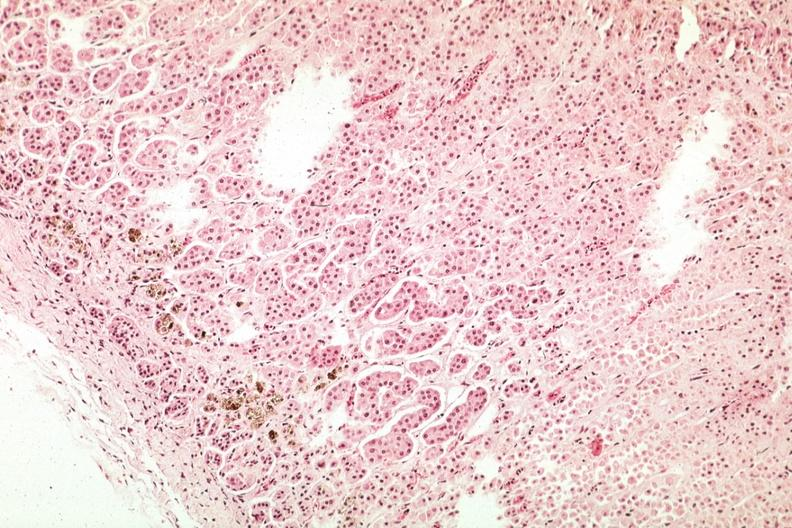s endocrine present?
Answer the question using a single word or phrase. Yes 